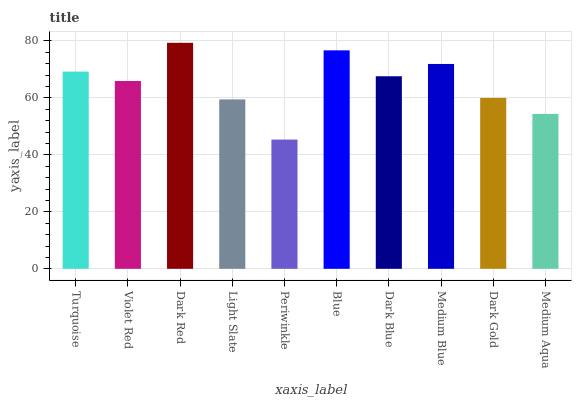Is Periwinkle the minimum?
Answer yes or no. Yes. Is Dark Red the maximum?
Answer yes or no. Yes. Is Violet Red the minimum?
Answer yes or no. No. Is Violet Red the maximum?
Answer yes or no. No. Is Turquoise greater than Violet Red?
Answer yes or no. Yes. Is Violet Red less than Turquoise?
Answer yes or no. Yes. Is Violet Red greater than Turquoise?
Answer yes or no. No. Is Turquoise less than Violet Red?
Answer yes or no. No. Is Dark Blue the high median?
Answer yes or no. Yes. Is Violet Red the low median?
Answer yes or no. Yes. Is Medium Blue the high median?
Answer yes or no. No. Is Blue the low median?
Answer yes or no. No. 